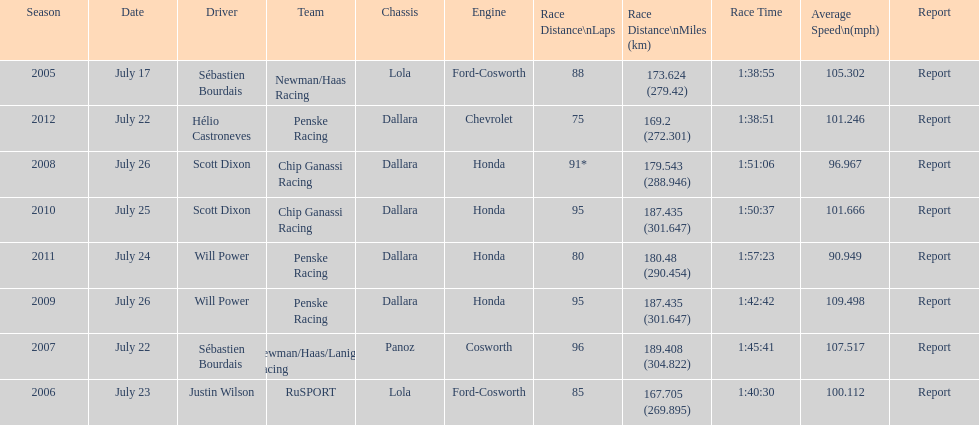What is the least amount of laps completed? 75. 